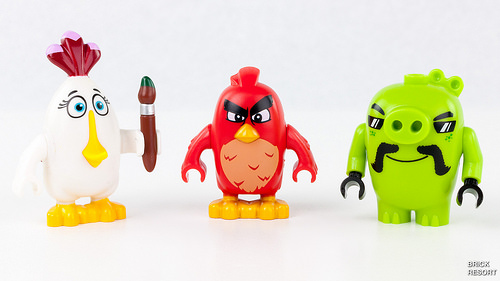<image>
Is the bird to the right of the pig? Yes. From this viewpoint, the bird is positioned to the right side relative to the pig. 